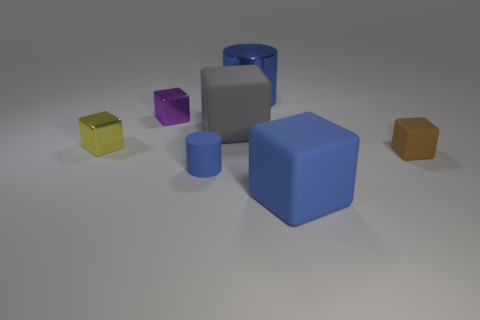There is a matte block that is to the left of the big blue thing that is in front of the tiny yellow metallic thing; how big is it?
Provide a succinct answer. Large. There is a big metal cylinder that is behind the large blue cube; is it the same color as the tiny rubber object left of the big blue matte block?
Your answer should be very brief. Yes. What number of cylinders are in front of the large blue object that is in front of the cylinder that is to the left of the big blue shiny cylinder?
Your response must be concise. 0. What number of objects are to the left of the blue matte cylinder and to the right of the yellow block?
Provide a succinct answer. 1. Are there more rubber blocks right of the gray rubber thing than gray metal cylinders?
Offer a very short reply. Yes. How many gray metallic cylinders are the same size as the yellow shiny block?
Offer a very short reply. 0. There is a matte cylinder that is the same color as the big shiny object; what size is it?
Provide a short and direct response. Small. What number of big things are purple metallic blocks or cyan shiny spheres?
Keep it short and to the point. 0. How many tiny blue metallic cylinders are there?
Offer a very short reply. 0. Are there the same number of cylinders that are behind the large cylinder and small objects that are on the left side of the big blue matte thing?
Your answer should be very brief. No. 